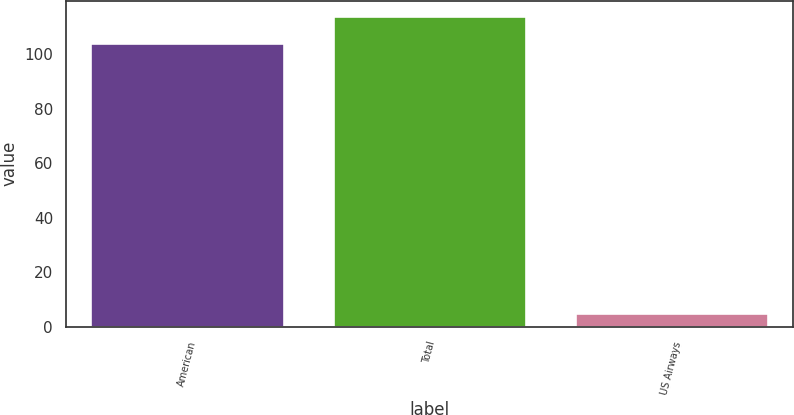Convert chart to OTSL. <chart><loc_0><loc_0><loc_500><loc_500><bar_chart><fcel>American<fcel>Total<fcel>US Airways<nl><fcel>104<fcel>113.9<fcel>5<nl></chart> 